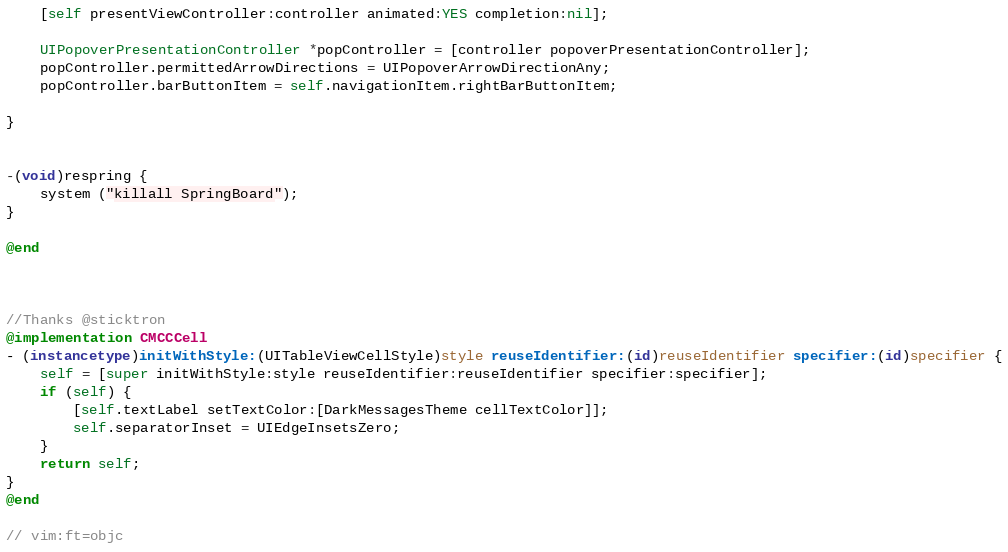Convert code to text. <code><loc_0><loc_0><loc_500><loc_500><_ObjectiveC_>    [self presentViewController:controller animated:YES completion:nil];
    
    UIPopoverPresentationController *popController = [controller popoverPresentationController];
    popController.permittedArrowDirections = UIPopoverArrowDirectionAny;
    popController.barButtonItem = self.navigationItem.rightBarButtonItem;
 
}


-(void)respring {
    system ("killall SpringBoard");
}

@end



//Thanks @sticktron
@implementation CMCCCell
- (instancetype)initWithStyle:(UITableViewCellStyle)style reuseIdentifier:(id)reuseIdentifier specifier:(id)specifier {
	self = [super initWithStyle:style reuseIdentifier:reuseIdentifier specifier:specifier];
	if (self) {
		[self.textLabel setTextColor:[DarkMessagesTheme cellTextColor]];
		self.separatorInset = UIEdgeInsetsZero;
	}
	return self;
}
@end

// vim:ft=objc
</code> 